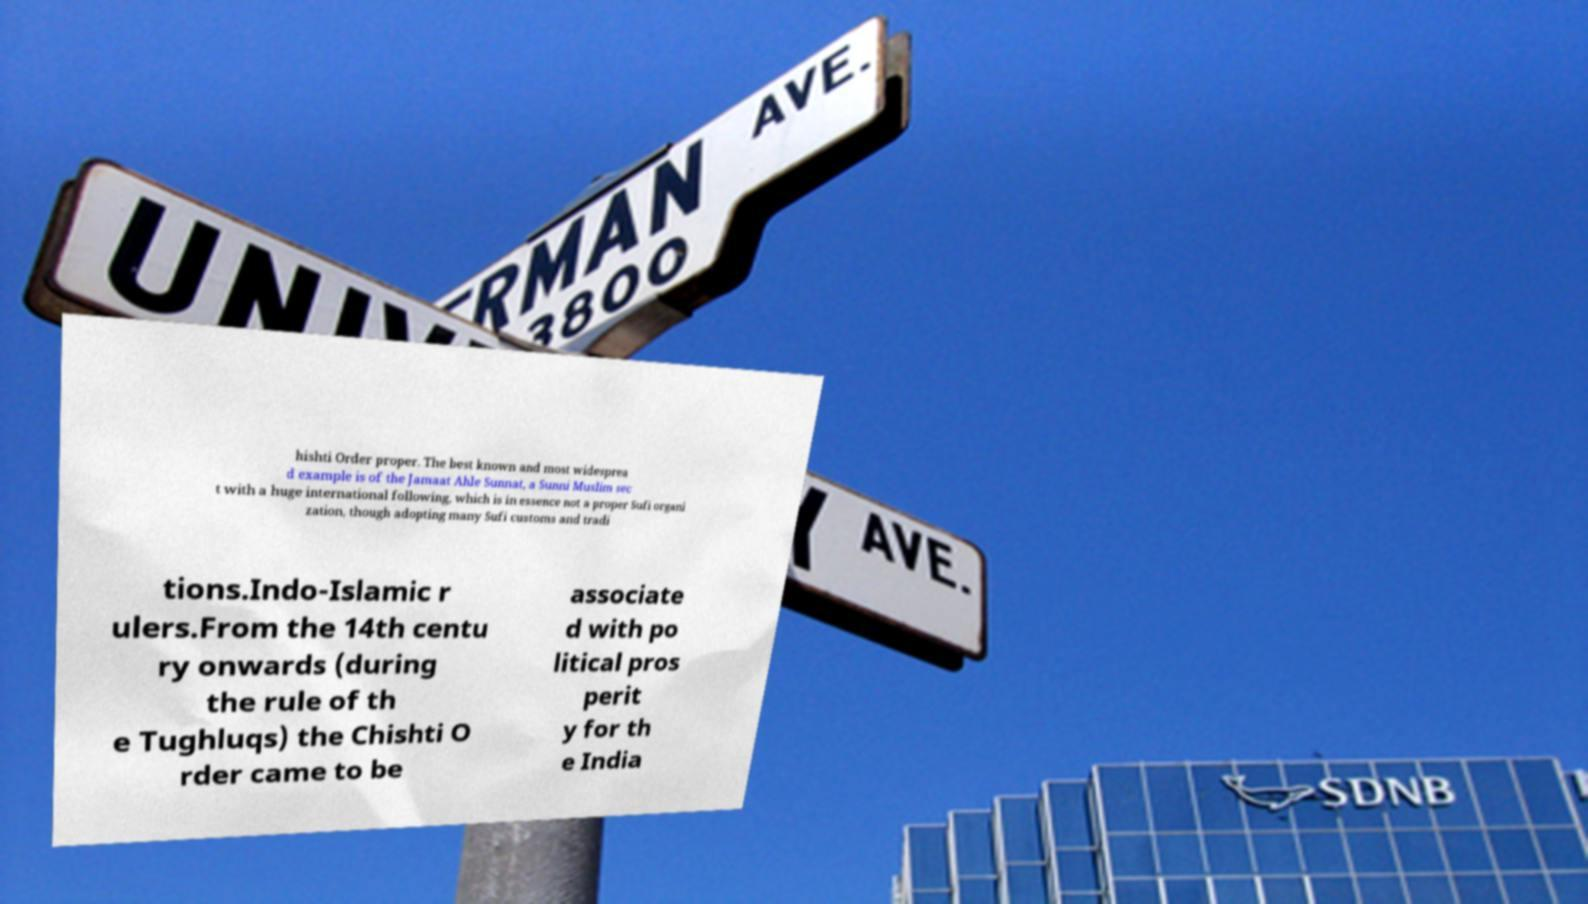For documentation purposes, I need the text within this image transcribed. Could you provide that? hishti Order proper. The best known and most widesprea d example is of the Jamaat Ahle Sunnat, a Sunni Muslim sec t with a huge international following, which is in essence not a proper Sufi organi zation, though adopting many Sufi customs and tradi tions.Indo-Islamic r ulers.From the 14th centu ry onwards (during the rule of th e Tughluqs) the Chishti O rder came to be associate d with po litical pros perit y for th e India 